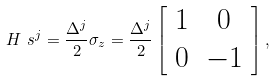<formula> <loc_0><loc_0><loc_500><loc_500>H _ { \ } s ^ { j } = \frac { \Delta ^ { j } } { 2 } \sigma _ { z } = \frac { \Delta ^ { j } } { 2 } \left [ \begin{array} { c c } 1 & 0 \\ 0 & - 1 \end{array} \right ] ,</formula> 